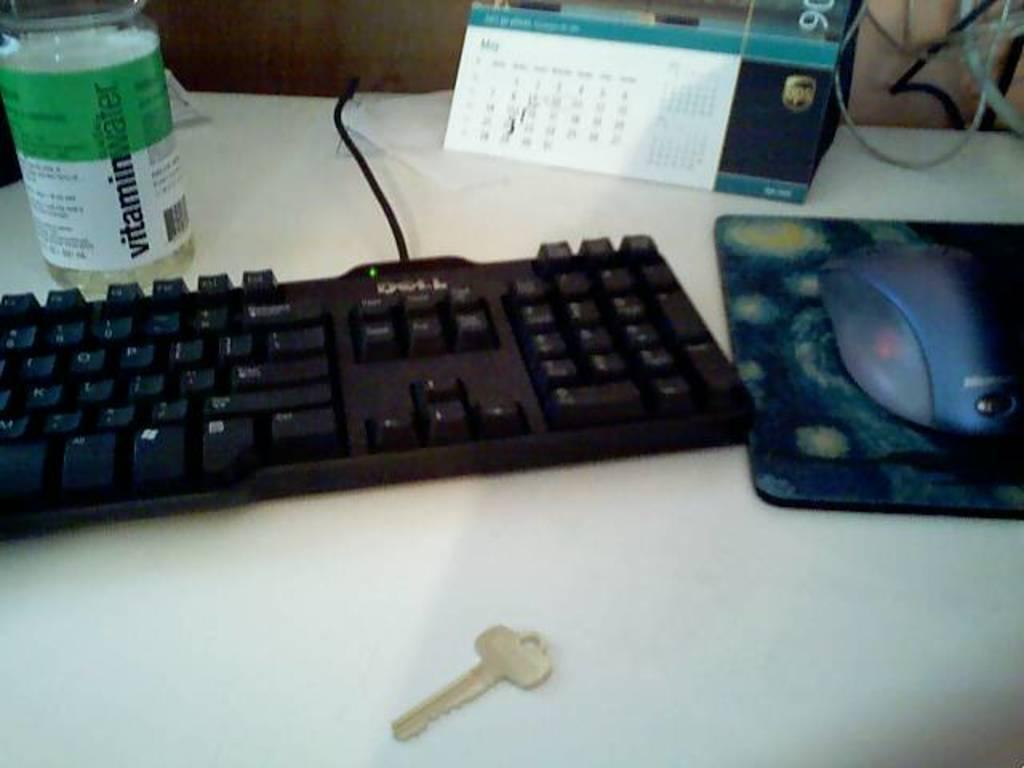<image>
Relay a brief, clear account of the picture shown. A key, a keyboard, a mouse, a calendar, and a bottle of vitamin water are on a desk. 